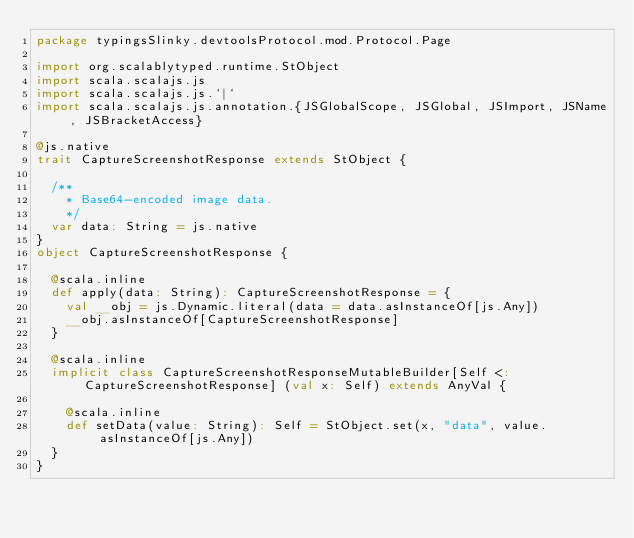Convert code to text. <code><loc_0><loc_0><loc_500><loc_500><_Scala_>package typingsSlinky.devtoolsProtocol.mod.Protocol.Page

import org.scalablytyped.runtime.StObject
import scala.scalajs.js
import scala.scalajs.js.`|`
import scala.scalajs.js.annotation.{JSGlobalScope, JSGlobal, JSImport, JSName, JSBracketAccess}

@js.native
trait CaptureScreenshotResponse extends StObject {
  
  /**
    * Base64-encoded image data.
    */
  var data: String = js.native
}
object CaptureScreenshotResponse {
  
  @scala.inline
  def apply(data: String): CaptureScreenshotResponse = {
    val __obj = js.Dynamic.literal(data = data.asInstanceOf[js.Any])
    __obj.asInstanceOf[CaptureScreenshotResponse]
  }
  
  @scala.inline
  implicit class CaptureScreenshotResponseMutableBuilder[Self <: CaptureScreenshotResponse] (val x: Self) extends AnyVal {
    
    @scala.inline
    def setData(value: String): Self = StObject.set(x, "data", value.asInstanceOf[js.Any])
  }
}
</code> 